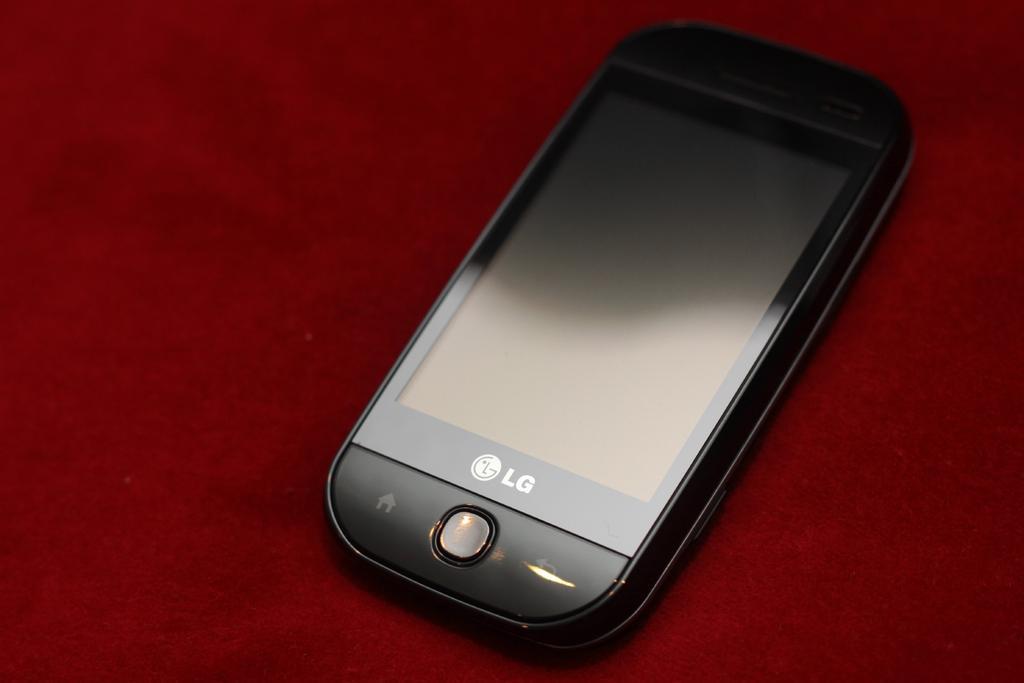How would you summarize this image in a sentence or two? In this image we can see a mobile on a red color platform. 